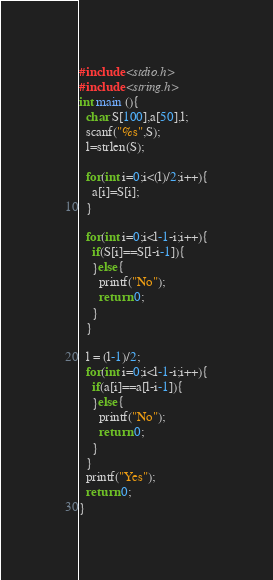<code> <loc_0><loc_0><loc_500><loc_500><_C_>#include <stdio.h>
#include <string.h>
int main (){
  char S[100],a[50],l;
  scanf("%s",S);
  l=strlen(S);
  
  for(int i=0;i<(l)/2;i++){
    a[i]=S[i];
  }
  
  for(int i=0;i<l-1-i;i++){
    if(S[i]==S[l-i-1]){
    }else{
      printf("No");
      return 0;
    }
  }
  
  l = (l-1)/2;
  for(int i=0;i<l-1-i;i++){
    if(a[i]==a[l-i-1]){
    }else{
      printf("No");
      return 0;
    }
  }
  printf("Yes");
  return 0;
}
</code> 